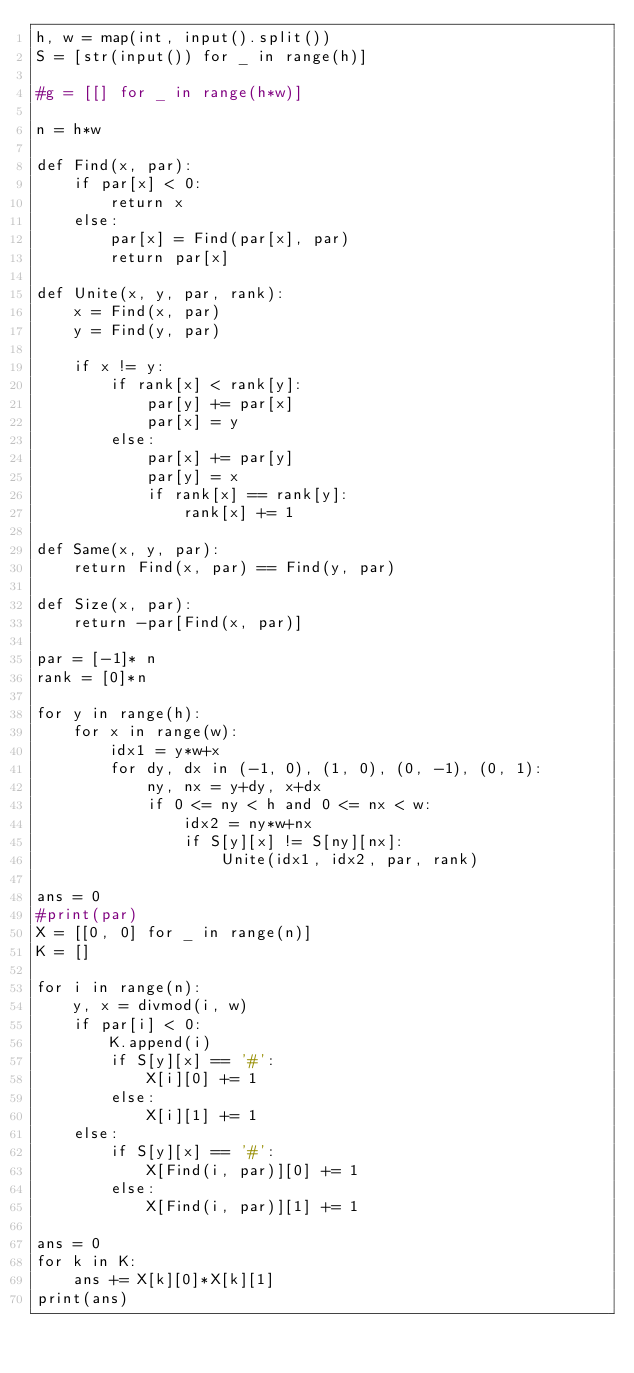<code> <loc_0><loc_0><loc_500><loc_500><_Python_>h, w = map(int, input().split())
S = [str(input()) for _ in range(h)]

#g = [[] for _ in range(h*w)]

n = h*w

def Find(x, par):
    if par[x] < 0:
        return x
    else:
        par[x] = Find(par[x], par)
        return par[x]

def Unite(x, y, par, rank):
    x = Find(x, par)
    y = Find(y, par)

    if x != y:
        if rank[x] < rank[y]:
            par[y] += par[x]
            par[x] = y
        else:
            par[x] += par[y]
            par[y] = x
            if rank[x] == rank[y]:
                rank[x] += 1

def Same(x, y, par):
    return Find(x, par) == Find(y, par)

def Size(x, par):
    return -par[Find(x, par)]

par = [-1]* n
rank = [0]*n

for y in range(h):
    for x in range(w):
        idx1 = y*w+x
        for dy, dx in (-1, 0), (1, 0), (0, -1), (0, 1):
            ny, nx = y+dy, x+dx
            if 0 <= ny < h and 0 <= nx < w:
                idx2 = ny*w+nx
                if S[y][x] != S[ny][nx]:
                    Unite(idx1, idx2, par, rank)

ans = 0
#print(par)
X = [[0, 0] for _ in range(n)]
K = []

for i in range(n):
    y, x = divmod(i, w)
    if par[i] < 0:
        K.append(i)
        if S[y][x] == '#':
            X[i][0] += 1
        else:
            X[i][1] += 1
    else:
        if S[y][x] == '#':
            X[Find(i, par)][0] += 1
        else:
            X[Find(i, par)][1] += 1

ans = 0
for k in K:
    ans += X[k][0]*X[k][1]
print(ans)</code> 